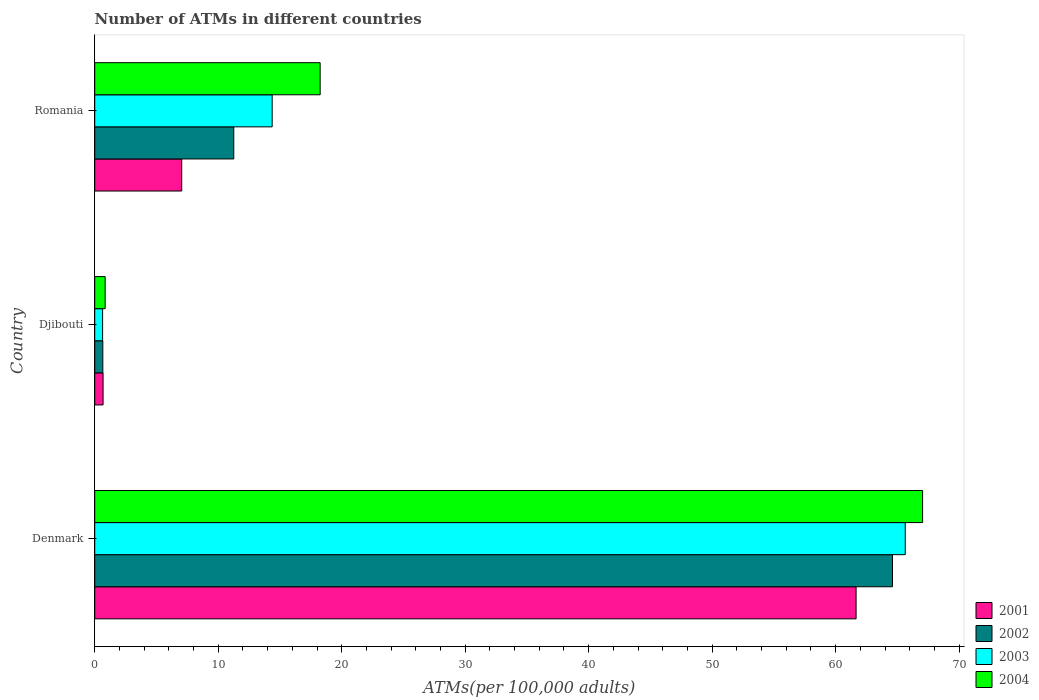How many different coloured bars are there?
Make the answer very short. 4. How many groups of bars are there?
Offer a very short reply. 3. Are the number of bars per tick equal to the number of legend labels?
Give a very brief answer. Yes. Are the number of bars on each tick of the Y-axis equal?
Make the answer very short. Yes. What is the label of the 2nd group of bars from the top?
Offer a terse response. Djibouti. In how many cases, is the number of bars for a given country not equal to the number of legend labels?
Ensure brevity in your answer.  0. What is the number of ATMs in 2003 in Djibouti?
Give a very brief answer. 0.64. Across all countries, what is the maximum number of ATMs in 2001?
Keep it short and to the point. 61.66. Across all countries, what is the minimum number of ATMs in 2003?
Your answer should be compact. 0.64. In which country was the number of ATMs in 2001 minimum?
Your answer should be very brief. Djibouti. What is the total number of ATMs in 2002 in the graph?
Offer a very short reply. 76.52. What is the difference between the number of ATMs in 2001 in Denmark and that in Romania?
Provide a short and direct response. 54.61. What is the difference between the number of ATMs in 2001 in Romania and the number of ATMs in 2003 in Denmark?
Provide a short and direct response. -58.59. What is the average number of ATMs in 2003 per country?
Ensure brevity in your answer.  26.88. What is the difference between the number of ATMs in 2004 and number of ATMs in 2001 in Denmark?
Your answer should be very brief. 5.39. In how many countries, is the number of ATMs in 2004 greater than 42 ?
Provide a succinct answer. 1. What is the ratio of the number of ATMs in 2004 in Denmark to that in Romania?
Provide a short and direct response. 3.67. Is the number of ATMs in 2003 in Denmark less than that in Romania?
Provide a succinct answer. No. What is the difference between the highest and the second highest number of ATMs in 2003?
Make the answer very short. 51.27. What is the difference between the highest and the lowest number of ATMs in 2004?
Ensure brevity in your answer.  66.2. In how many countries, is the number of ATMs in 2003 greater than the average number of ATMs in 2003 taken over all countries?
Provide a succinct answer. 1. Is the sum of the number of ATMs in 2001 in Denmark and Djibouti greater than the maximum number of ATMs in 2002 across all countries?
Your answer should be compact. No. Is it the case that in every country, the sum of the number of ATMs in 2004 and number of ATMs in 2003 is greater than the sum of number of ATMs in 2002 and number of ATMs in 2001?
Provide a succinct answer. No. Is it the case that in every country, the sum of the number of ATMs in 2002 and number of ATMs in 2003 is greater than the number of ATMs in 2004?
Your answer should be compact. Yes. How many bars are there?
Give a very brief answer. 12. Are all the bars in the graph horizontal?
Ensure brevity in your answer.  Yes. How many countries are there in the graph?
Your answer should be compact. 3. Are the values on the major ticks of X-axis written in scientific E-notation?
Your answer should be compact. No. Where does the legend appear in the graph?
Your answer should be very brief. Bottom right. What is the title of the graph?
Ensure brevity in your answer.  Number of ATMs in different countries. Does "1965" appear as one of the legend labels in the graph?
Your answer should be very brief. No. What is the label or title of the X-axis?
Your response must be concise. ATMs(per 100,0 adults). What is the label or title of the Y-axis?
Ensure brevity in your answer.  Country. What is the ATMs(per 100,000 adults) of 2001 in Denmark?
Your answer should be very brief. 61.66. What is the ATMs(per 100,000 adults) of 2002 in Denmark?
Provide a succinct answer. 64.61. What is the ATMs(per 100,000 adults) in 2003 in Denmark?
Your answer should be very brief. 65.64. What is the ATMs(per 100,000 adults) in 2004 in Denmark?
Give a very brief answer. 67.04. What is the ATMs(per 100,000 adults) of 2001 in Djibouti?
Offer a very short reply. 0.68. What is the ATMs(per 100,000 adults) in 2002 in Djibouti?
Make the answer very short. 0.66. What is the ATMs(per 100,000 adults) of 2003 in Djibouti?
Ensure brevity in your answer.  0.64. What is the ATMs(per 100,000 adults) in 2004 in Djibouti?
Your answer should be compact. 0.84. What is the ATMs(per 100,000 adults) in 2001 in Romania?
Your answer should be very brief. 7.04. What is the ATMs(per 100,000 adults) in 2002 in Romania?
Your response must be concise. 11.26. What is the ATMs(per 100,000 adults) of 2003 in Romania?
Provide a succinct answer. 14.37. What is the ATMs(per 100,000 adults) in 2004 in Romania?
Keep it short and to the point. 18.26. Across all countries, what is the maximum ATMs(per 100,000 adults) in 2001?
Your response must be concise. 61.66. Across all countries, what is the maximum ATMs(per 100,000 adults) in 2002?
Keep it short and to the point. 64.61. Across all countries, what is the maximum ATMs(per 100,000 adults) in 2003?
Your answer should be very brief. 65.64. Across all countries, what is the maximum ATMs(per 100,000 adults) in 2004?
Your response must be concise. 67.04. Across all countries, what is the minimum ATMs(per 100,000 adults) of 2001?
Keep it short and to the point. 0.68. Across all countries, what is the minimum ATMs(per 100,000 adults) of 2002?
Your answer should be compact. 0.66. Across all countries, what is the minimum ATMs(per 100,000 adults) in 2003?
Make the answer very short. 0.64. Across all countries, what is the minimum ATMs(per 100,000 adults) in 2004?
Offer a terse response. 0.84. What is the total ATMs(per 100,000 adults) of 2001 in the graph?
Offer a terse response. 69.38. What is the total ATMs(per 100,000 adults) of 2002 in the graph?
Your answer should be very brief. 76.52. What is the total ATMs(per 100,000 adults) of 2003 in the graph?
Offer a very short reply. 80.65. What is the total ATMs(per 100,000 adults) of 2004 in the graph?
Provide a short and direct response. 86.14. What is the difference between the ATMs(per 100,000 adults) in 2001 in Denmark and that in Djibouti?
Keep it short and to the point. 60.98. What is the difference between the ATMs(per 100,000 adults) of 2002 in Denmark and that in Djibouti?
Your response must be concise. 63.95. What is the difference between the ATMs(per 100,000 adults) in 2003 in Denmark and that in Djibouti?
Provide a succinct answer. 65. What is the difference between the ATMs(per 100,000 adults) of 2004 in Denmark and that in Djibouti?
Offer a terse response. 66.2. What is the difference between the ATMs(per 100,000 adults) of 2001 in Denmark and that in Romania?
Provide a short and direct response. 54.61. What is the difference between the ATMs(per 100,000 adults) of 2002 in Denmark and that in Romania?
Make the answer very short. 53.35. What is the difference between the ATMs(per 100,000 adults) of 2003 in Denmark and that in Romania?
Your answer should be very brief. 51.27. What is the difference between the ATMs(per 100,000 adults) of 2004 in Denmark and that in Romania?
Ensure brevity in your answer.  48.79. What is the difference between the ATMs(per 100,000 adults) of 2001 in Djibouti and that in Romania?
Ensure brevity in your answer.  -6.37. What is the difference between the ATMs(per 100,000 adults) in 2002 in Djibouti and that in Romania?
Your response must be concise. -10.6. What is the difference between the ATMs(per 100,000 adults) of 2003 in Djibouti and that in Romania?
Offer a very short reply. -13.73. What is the difference between the ATMs(per 100,000 adults) of 2004 in Djibouti and that in Romania?
Make the answer very short. -17.41. What is the difference between the ATMs(per 100,000 adults) of 2001 in Denmark and the ATMs(per 100,000 adults) of 2002 in Djibouti?
Your answer should be compact. 61. What is the difference between the ATMs(per 100,000 adults) of 2001 in Denmark and the ATMs(per 100,000 adults) of 2003 in Djibouti?
Your answer should be compact. 61.02. What is the difference between the ATMs(per 100,000 adults) of 2001 in Denmark and the ATMs(per 100,000 adults) of 2004 in Djibouti?
Offer a terse response. 60.81. What is the difference between the ATMs(per 100,000 adults) in 2002 in Denmark and the ATMs(per 100,000 adults) in 2003 in Djibouti?
Provide a succinct answer. 63.97. What is the difference between the ATMs(per 100,000 adults) of 2002 in Denmark and the ATMs(per 100,000 adults) of 2004 in Djibouti?
Offer a very short reply. 63.76. What is the difference between the ATMs(per 100,000 adults) in 2003 in Denmark and the ATMs(per 100,000 adults) in 2004 in Djibouti?
Provide a succinct answer. 64.79. What is the difference between the ATMs(per 100,000 adults) of 2001 in Denmark and the ATMs(per 100,000 adults) of 2002 in Romania?
Offer a very short reply. 50.4. What is the difference between the ATMs(per 100,000 adults) in 2001 in Denmark and the ATMs(per 100,000 adults) in 2003 in Romania?
Your response must be concise. 47.29. What is the difference between the ATMs(per 100,000 adults) in 2001 in Denmark and the ATMs(per 100,000 adults) in 2004 in Romania?
Offer a terse response. 43.4. What is the difference between the ATMs(per 100,000 adults) in 2002 in Denmark and the ATMs(per 100,000 adults) in 2003 in Romania?
Provide a short and direct response. 50.24. What is the difference between the ATMs(per 100,000 adults) in 2002 in Denmark and the ATMs(per 100,000 adults) in 2004 in Romania?
Provide a short and direct response. 46.35. What is the difference between the ATMs(per 100,000 adults) in 2003 in Denmark and the ATMs(per 100,000 adults) in 2004 in Romania?
Your answer should be compact. 47.38. What is the difference between the ATMs(per 100,000 adults) in 2001 in Djibouti and the ATMs(per 100,000 adults) in 2002 in Romania?
Provide a succinct answer. -10.58. What is the difference between the ATMs(per 100,000 adults) of 2001 in Djibouti and the ATMs(per 100,000 adults) of 2003 in Romania?
Provide a short and direct response. -13.69. What is the difference between the ATMs(per 100,000 adults) of 2001 in Djibouti and the ATMs(per 100,000 adults) of 2004 in Romania?
Keep it short and to the point. -17.58. What is the difference between the ATMs(per 100,000 adults) of 2002 in Djibouti and the ATMs(per 100,000 adults) of 2003 in Romania?
Offer a terse response. -13.71. What is the difference between the ATMs(per 100,000 adults) of 2002 in Djibouti and the ATMs(per 100,000 adults) of 2004 in Romania?
Provide a succinct answer. -17.6. What is the difference between the ATMs(per 100,000 adults) of 2003 in Djibouti and the ATMs(per 100,000 adults) of 2004 in Romania?
Keep it short and to the point. -17.62. What is the average ATMs(per 100,000 adults) in 2001 per country?
Keep it short and to the point. 23.13. What is the average ATMs(per 100,000 adults) in 2002 per country?
Your answer should be very brief. 25.51. What is the average ATMs(per 100,000 adults) of 2003 per country?
Provide a succinct answer. 26.88. What is the average ATMs(per 100,000 adults) of 2004 per country?
Your response must be concise. 28.71. What is the difference between the ATMs(per 100,000 adults) in 2001 and ATMs(per 100,000 adults) in 2002 in Denmark?
Your answer should be very brief. -2.95. What is the difference between the ATMs(per 100,000 adults) of 2001 and ATMs(per 100,000 adults) of 2003 in Denmark?
Give a very brief answer. -3.98. What is the difference between the ATMs(per 100,000 adults) in 2001 and ATMs(per 100,000 adults) in 2004 in Denmark?
Make the answer very short. -5.39. What is the difference between the ATMs(per 100,000 adults) of 2002 and ATMs(per 100,000 adults) of 2003 in Denmark?
Keep it short and to the point. -1.03. What is the difference between the ATMs(per 100,000 adults) of 2002 and ATMs(per 100,000 adults) of 2004 in Denmark?
Ensure brevity in your answer.  -2.44. What is the difference between the ATMs(per 100,000 adults) in 2003 and ATMs(per 100,000 adults) in 2004 in Denmark?
Provide a short and direct response. -1.41. What is the difference between the ATMs(per 100,000 adults) of 2001 and ATMs(per 100,000 adults) of 2002 in Djibouti?
Your response must be concise. 0.02. What is the difference between the ATMs(per 100,000 adults) of 2001 and ATMs(per 100,000 adults) of 2003 in Djibouti?
Ensure brevity in your answer.  0.04. What is the difference between the ATMs(per 100,000 adults) in 2001 and ATMs(per 100,000 adults) in 2004 in Djibouti?
Provide a succinct answer. -0.17. What is the difference between the ATMs(per 100,000 adults) of 2002 and ATMs(per 100,000 adults) of 2003 in Djibouti?
Keep it short and to the point. 0.02. What is the difference between the ATMs(per 100,000 adults) of 2002 and ATMs(per 100,000 adults) of 2004 in Djibouti?
Offer a very short reply. -0.19. What is the difference between the ATMs(per 100,000 adults) of 2003 and ATMs(per 100,000 adults) of 2004 in Djibouti?
Provide a succinct answer. -0.21. What is the difference between the ATMs(per 100,000 adults) in 2001 and ATMs(per 100,000 adults) in 2002 in Romania?
Provide a succinct answer. -4.21. What is the difference between the ATMs(per 100,000 adults) in 2001 and ATMs(per 100,000 adults) in 2003 in Romania?
Provide a short and direct response. -7.32. What is the difference between the ATMs(per 100,000 adults) in 2001 and ATMs(per 100,000 adults) in 2004 in Romania?
Your response must be concise. -11.21. What is the difference between the ATMs(per 100,000 adults) in 2002 and ATMs(per 100,000 adults) in 2003 in Romania?
Your answer should be compact. -3.11. What is the difference between the ATMs(per 100,000 adults) of 2002 and ATMs(per 100,000 adults) of 2004 in Romania?
Keep it short and to the point. -7. What is the difference between the ATMs(per 100,000 adults) of 2003 and ATMs(per 100,000 adults) of 2004 in Romania?
Make the answer very short. -3.89. What is the ratio of the ATMs(per 100,000 adults) of 2001 in Denmark to that in Djibouti?
Provide a succinct answer. 91.18. What is the ratio of the ATMs(per 100,000 adults) of 2002 in Denmark to that in Djibouti?
Provide a short and direct response. 98.45. What is the ratio of the ATMs(per 100,000 adults) of 2003 in Denmark to that in Djibouti?
Offer a terse response. 102.88. What is the ratio of the ATMs(per 100,000 adults) in 2004 in Denmark to that in Djibouti?
Ensure brevity in your answer.  79.46. What is the ratio of the ATMs(per 100,000 adults) of 2001 in Denmark to that in Romania?
Offer a terse response. 8.75. What is the ratio of the ATMs(per 100,000 adults) in 2002 in Denmark to that in Romania?
Provide a short and direct response. 5.74. What is the ratio of the ATMs(per 100,000 adults) of 2003 in Denmark to that in Romania?
Give a very brief answer. 4.57. What is the ratio of the ATMs(per 100,000 adults) in 2004 in Denmark to that in Romania?
Offer a terse response. 3.67. What is the ratio of the ATMs(per 100,000 adults) in 2001 in Djibouti to that in Romania?
Offer a terse response. 0.1. What is the ratio of the ATMs(per 100,000 adults) in 2002 in Djibouti to that in Romania?
Offer a terse response. 0.06. What is the ratio of the ATMs(per 100,000 adults) of 2003 in Djibouti to that in Romania?
Provide a succinct answer. 0.04. What is the ratio of the ATMs(per 100,000 adults) in 2004 in Djibouti to that in Romania?
Your answer should be very brief. 0.05. What is the difference between the highest and the second highest ATMs(per 100,000 adults) in 2001?
Offer a terse response. 54.61. What is the difference between the highest and the second highest ATMs(per 100,000 adults) of 2002?
Make the answer very short. 53.35. What is the difference between the highest and the second highest ATMs(per 100,000 adults) in 2003?
Give a very brief answer. 51.27. What is the difference between the highest and the second highest ATMs(per 100,000 adults) of 2004?
Your response must be concise. 48.79. What is the difference between the highest and the lowest ATMs(per 100,000 adults) of 2001?
Your response must be concise. 60.98. What is the difference between the highest and the lowest ATMs(per 100,000 adults) of 2002?
Keep it short and to the point. 63.95. What is the difference between the highest and the lowest ATMs(per 100,000 adults) of 2003?
Offer a very short reply. 65. What is the difference between the highest and the lowest ATMs(per 100,000 adults) of 2004?
Offer a very short reply. 66.2. 